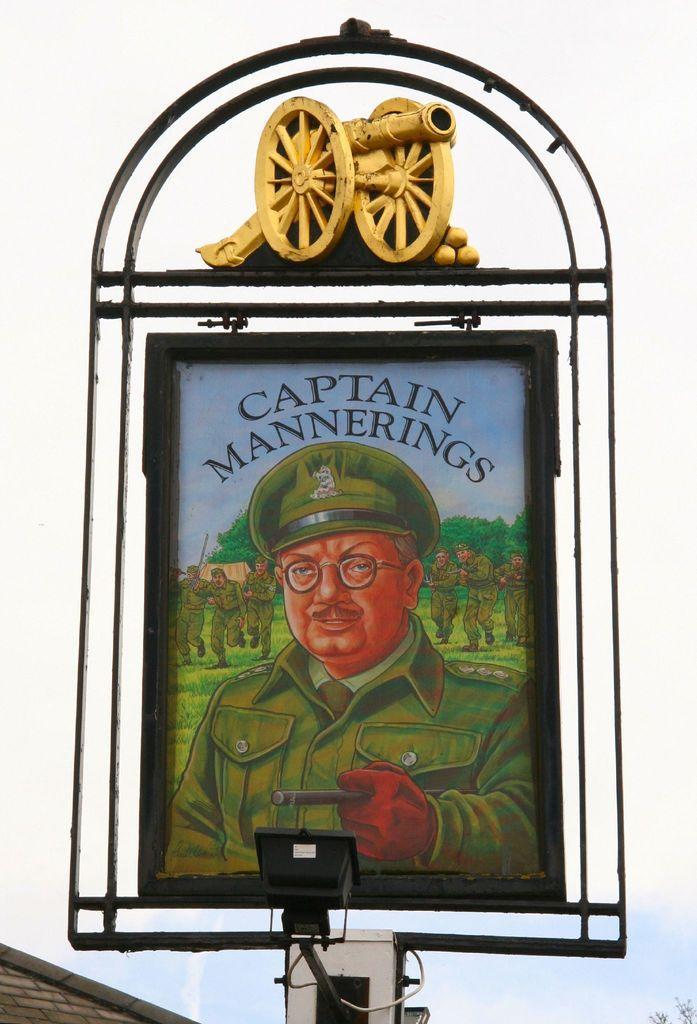Can you describe this image briefly? In this image we can see a board. On the board we can see picture of people, trees, ground, and sky. At the top of the board we can see a miniature vehicle. At the bottom of the image we can see a light. There is a white background. 